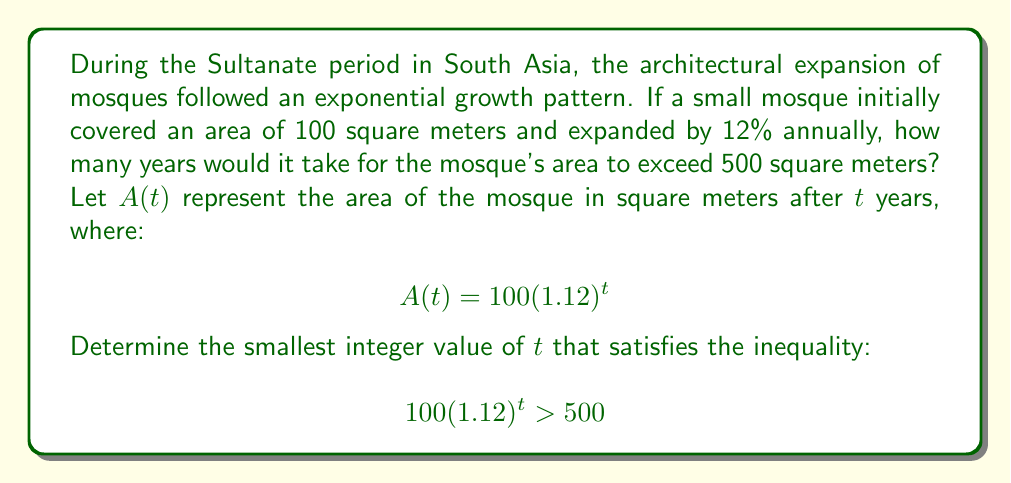Provide a solution to this math problem. To solve this problem, we'll use the properties of exponential functions and logarithms:

1) We start with the inequality:
   $$100(1.12)^t > 500$$

2) Divide both sides by 100:
   $$(1.12)^t > 5$$

3) Take the natural logarithm of both sides:
   $$\ln((1.12)^t) > \ln(5)$$

4) Using the logarithm property $\ln(a^b) = b\ln(a)$:
   $$t\ln(1.12) > \ln(5)$$

5) Divide both sides by $\ln(1.12)$:
   $$t > \frac{\ln(5)}{\ln(1.12)}$$

6) Calculate the right-hand side:
   $$t > \frac{\ln(5)}{\ln(1.12)} \approx 14.2747$$

7) Since we need the smallest integer value of $t$, we round up to the next whole number.

This problem is particularly relevant to the Sultanate period in South Asia, as it demonstrates the rapid expansion of Islamic architecture during this time, reflecting the growth and influence of Muslim rule in the region.
Answer: The mosque's area will exceed 500 square meters after 15 years. 